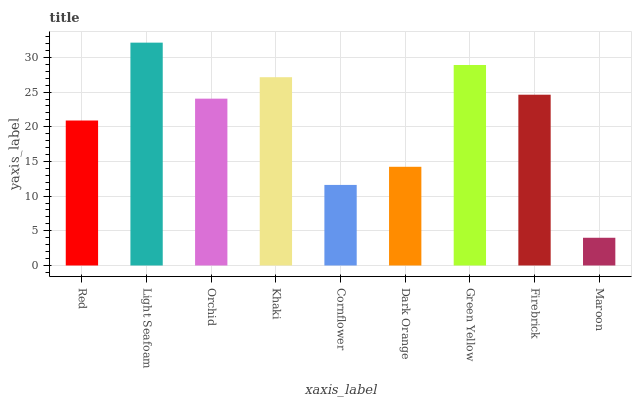Is Maroon the minimum?
Answer yes or no. Yes. Is Light Seafoam the maximum?
Answer yes or no. Yes. Is Orchid the minimum?
Answer yes or no. No. Is Orchid the maximum?
Answer yes or no. No. Is Light Seafoam greater than Orchid?
Answer yes or no. Yes. Is Orchid less than Light Seafoam?
Answer yes or no. Yes. Is Orchid greater than Light Seafoam?
Answer yes or no. No. Is Light Seafoam less than Orchid?
Answer yes or no. No. Is Orchid the high median?
Answer yes or no. Yes. Is Orchid the low median?
Answer yes or no. Yes. Is Firebrick the high median?
Answer yes or no. No. Is Red the low median?
Answer yes or no. No. 